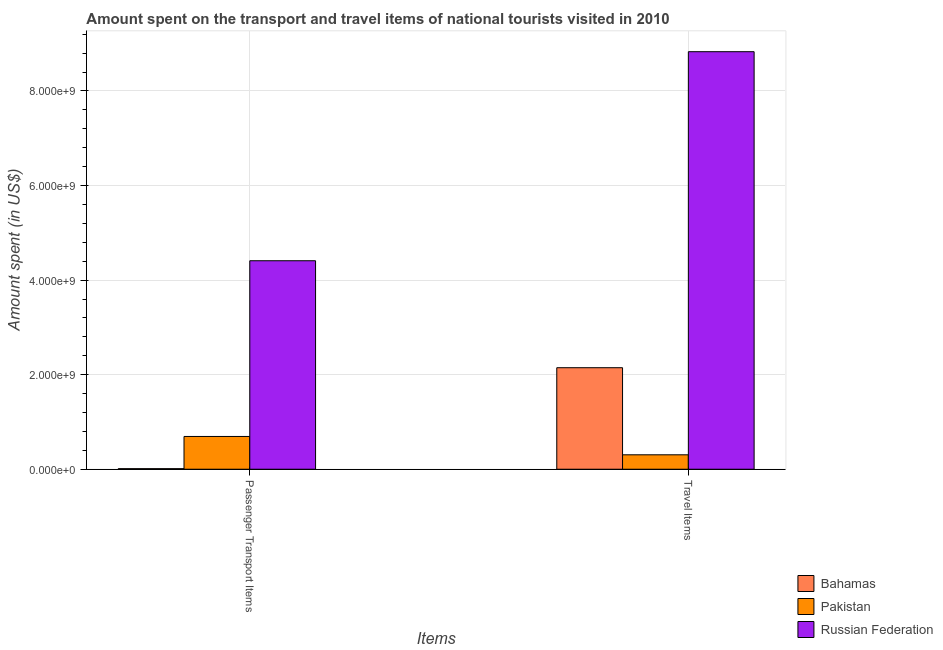How many different coloured bars are there?
Offer a terse response. 3. How many groups of bars are there?
Your answer should be compact. 2. Are the number of bars per tick equal to the number of legend labels?
Ensure brevity in your answer.  Yes. How many bars are there on the 1st tick from the left?
Your response must be concise. 3. What is the label of the 2nd group of bars from the left?
Ensure brevity in your answer.  Travel Items. What is the amount spent in travel items in Pakistan?
Give a very brief answer. 3.05e+08. Across all countries, what is the maximum amount spent on passenger transport items?
Ensure brevity in your answer.  4.41e+09. Across all countries, what is the minimum amount spent in travel items?
Give a very brief answer. 3.05e+08. In which country was the amount spent on passenger transport items maximum?
Make the answer very short. Russian Federation. In which country was the amount spent on passenger transport items minimum?
Your response must be concise. Bahamas. What is the total amount spent in travel items in the graph?
Provide a succinct answer. 1.13e+1. What is the difference between the amount spent on passenger transport items in Bahamas and that in Pakistan?
Provide a short and direct response. -6.81e+08. What is the difference between the amount spent in travel items in Russian Federation and the amount spent on passenger transport items in Bahamas?
Provide a short and direct response. 8.82e+09. What is the average amount spent in travel items per country?
Give a very brief answer. 3.76e+09. What is the difference between the amount spent on passenger transport items and amount spent in travel items in Bahamas?
Give a very brief answer. -2.14e+09. In how many countries, is the amount spent in travel items greater than 5200000000 US$?
Your response must be concise. 1. What is the ratio of the amount spent on passenger transport items in Russian Federation to that in Pakistan?
Ensure brevity in your answer.  6.36. Is the amount spent on passenger transport items in Russian Federation less than that in Pakistan?
Provide a short and direct response. No. In how many countries, is the amount spent on passenger transport items greater than the average amount spent on passenger transport items taken over all countries?
Ensure brevity in your answer.  1. What does the 2nd bar from the left in Passenger Transport Items represents?
Offer a terse response. Pakistan. What does the 3rd bar from the right in Passenger Transport Items represents?
Give a very brief answer. Bahamas. How many countries are there in the graph?
Your answer should be compact. 3. What is the difference between two consecutive major ticks on the Y-axis?
Offer a very short reply. 2.00e+09. Are the values on the major ticks of Y-axis written in scientific E-notation?
Offer a terse response. Yes. Does the graph contain any zero values?
Your answer should be very brief. No. Where does the legend appear in the graph?
Ensure brevity in your answer.  Bottom right. How are the legend labels stacked?
Your answer should be compact. Vertical. What is the title of the graph?
Offer a very short reply. Amount spent on the transport and travel items of national tourists visited in 2010. Does "Yemen, Rep." appear as one of the legend labels in the graph?
Provide a short and direct response. No. What is the label or title of the X-axis?
Your answer should be very brief. Items. What is the label or title of the Y-axis?
Keep it short and to the point. Amount spent (in US$). What is the Amount spent (in US$) in Bahamas in Passenger Transport Items?
Your answer should be very brief. 1.20e+07. What is the Amount spent (in US$) in Pakistan in Passenger Transport Items?
Provide a short and direct response. 6.93e+08. What is the Amount spent (in US$) in Russian Federation in Passenger Transport Items?
Make the answer very short. 4.41e+09. What is the Amount spent (in US$) of Bahamas in Travel Items?
Your answer should be very brief. 2.15e+09. What is the Amount spent (in US$) of Pakistan in Travel Items?
Offer a very short reply. 3.05e+08. What is the Amount spent (in US$) in Russian Federation in Travel Items?
Ensure brevity in your answer.  8.83e+09. Across all Items, what is the maximum Amount spent (in US$) in Bahamas?
Provide a succinct answer. 2.15e+09. Across all Items, what is the maximum Amount spent (in US$) in Pakistan?
Make the answer very short. 6.93e+08. Across all Items, what is the maximum Amount spent (in US$) of Russian Federation?
Offer a terse response. 8.83e+09. Across all Items, what is the minimum Amount spent (in US$) in Pakistan?
Make the answer very short. 3.05e+08. Across all Items, what is the minimum Amount spent (in US$) in Russian Federation?
Your answer should be compact. 4.41e+09. What is the total Amount spent (in US$) of Bahamas in the graph?
Your answer should be compact. 2.16e+09. What is the total Amount spent (in US$) of Pakistan in the graph?
Make the answer very short. 9.98e+08. What is the total Amount spent (in US$) of Russian Federation in the graph?
Keep it short and to the point. 1.32e+1. What is the difference between the Amount spent (in US$) of Bahamas in Passenger Transport Items and that in Travel Items?
Provide a short and direct response. -2.14e+09. What is the difference between the Amount spent (in US$) in Pakistan in Passenger Transport Items and that in Travel Items?
Your answer should be very brief. 3.88e+08. What is the difference between the Amount spent (in US$) in Russian Federation in Passenger Transport Items and that in Travel Items?
Ensure brevity in your answer.  -4.42e+09. What is the difference between the Amount spent (in US$) of Bahamas in Passenger Transport Items and the Amount spent (in US$) of Pakistan in Travel Items?
Keep it short and to the point. -2.93e+08. What is the difference between the Amount spent (in US$) in Bahamas in Passenger Transport Items and the Amount spent (in US$) in Russian Federation in Travel Items?
Your answer should be very brief. -8.82e+09. What is the difference between the Amount spent (in US$) in Pakistan in Passenger Transport Items and the Amount spent (in US$) in Russian Federation in Travel Items?
Your answer should be very brief. -8.14e+09. What is the average Amount spent (in US$) in Bahamas per Items?
Ensure brevity in your answer.  1.08e+09. What is the average Amount spent (in US$) in Pakistan per Items?
Your answer should be very brief. 4.99e+08. What is the average Amount spent (in US$) in Russian Federation per Items?
Keep it short and to the point. 6.62e+09. What is the difference between the Amount spent (in US$) of Bahamas and Amount spent (in US$) of Pakistan in Passenger Transport Items?
Give a very brief answer. -6.81e+08. What is the difference between the Amount spent (in US$) in Bahamas and Amount spent (in US$) in Russian Federation in Passenger Transport Items?
Give a very brief answer. -4.40e+09. What is the difference between the Amount spent (in US$) in Pakistan and Amount spent (in US$) in Russian Federation in Passenger Transport Items?
Provide a succinct answer. -3.72e+09. What is the difference between the Amount spent (in US$) of Bahamas and Amount spent (in US$) of Pakistan in Travel Items?
Provide a short and direct response. 1.84e+09. What is the difference between the Amount spent (in US$) in Bahamas and Amount spent (in US$) in Russian Federation in Travel Items?
Provide a short and direct response. -6.68e+09. What is the difference between the Amount spent (in US$) in Pakistan and Amount spent (in US$) in Russian Federation in Travel Items?
Give a very brief answer. -8.52e+09. What is the ratio of the Amount spent (in US$) of Bahamas in Passenger Transport Items to that in Travel Items?
Your answer should be compact. 0.01. What is the ratio of the Amount spent (in US$) of Pakistan in Passenger Transport Items to that in Travel Items?
Ensure brevity in your answer.  2.27. What is the ratio of the Amount spent (in US$) in Russian Federation in Passenger Transport Items to that in Travel Items?
Provide a succinct answer. 0.5. What is the difference between the highest and the second highest Amount spent (in US$) in Bahamas?
Offer a terse response. 2.14e+09. What is the difference between the highest and the second highest Amount spent (in US$) in Pakistan?
Provide a succinct answer. 3.88e+08. What is the difference between the highest and the second highest Amount spent (in US$) of Russian Federation?
Your answer should be compact. 4.42e+09. What is the difference between the highest and the lowest Amount spent (in US$) of Bahamas?
Offer a very short reply. 2.14e+09. What is the difference between the highest and the lowest Amount spent (in US$) of Pakistan?
Provide a succinct answer. 3.88e+08. What is the difference between the highest and the lowest Amount spent (in US$) of Russian Federation?
Make the answer very short. 4.42e+09. 